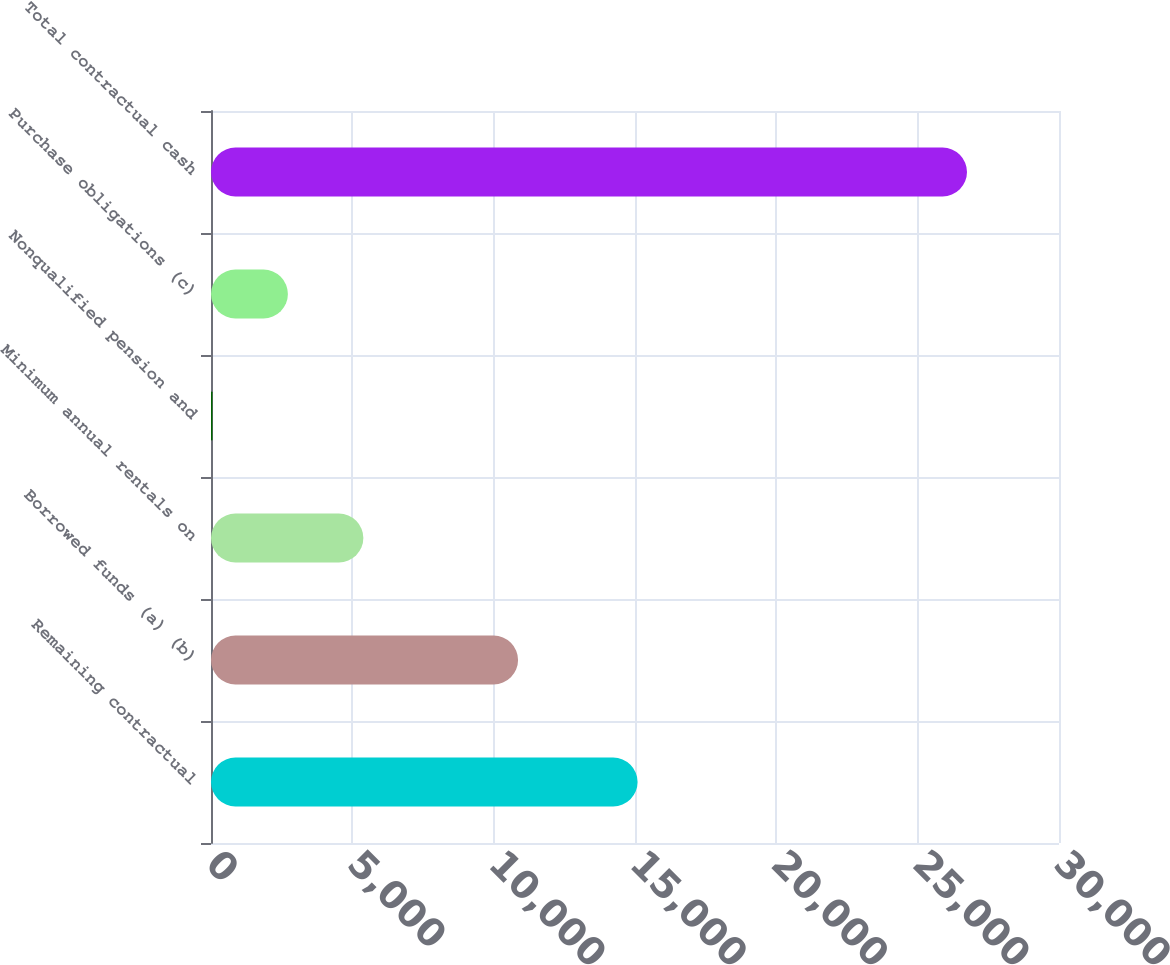Convert chart to OTSL. <chart><loc_0><loc_0><loc_500><loc_500><bar_chart><fcel>Remaining contractual<fcel>Borrowed funds (a) (b)<fcel>Minimum annual rentals on<fcel>Nonqualified pension and<fcel>Purchase obligations (c)<fcel>Total contractual cash<nl><fcel>15092<fcel>10863<fcel>5389.8<fcel>51<fcel>2720.4<fcel>26745<nl></chart> 